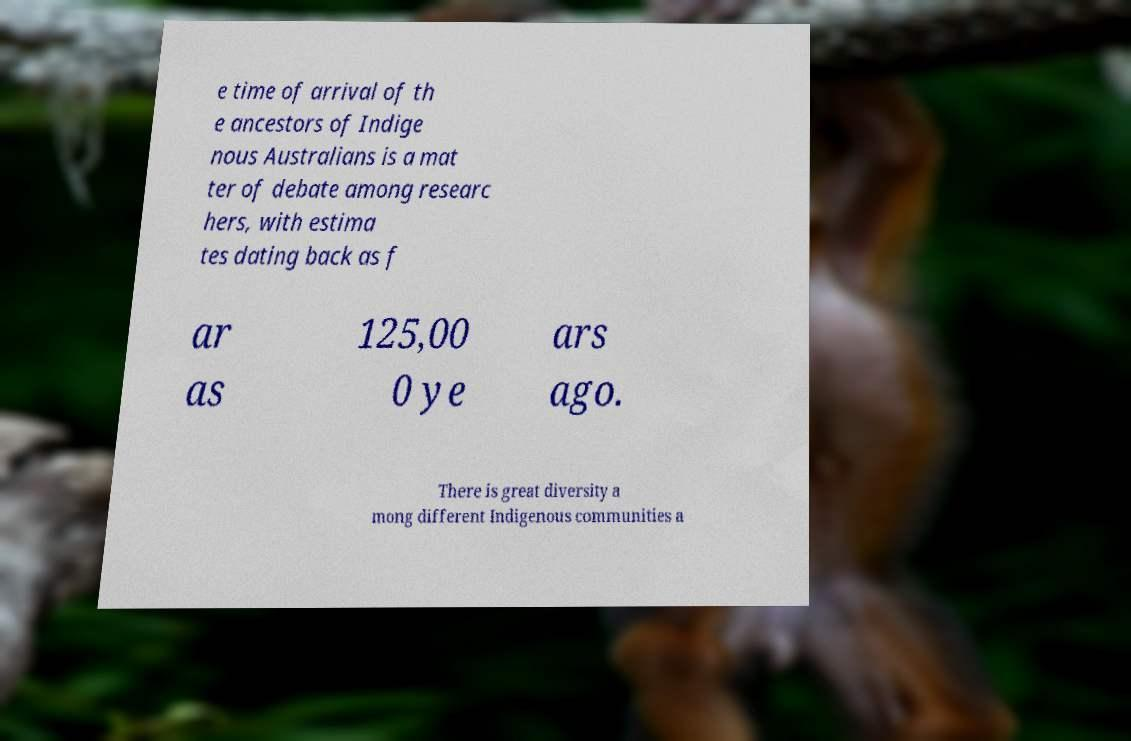Could you assist in decoding the text presented in this image and type it out clearly? e time of arrival of th e ancestors of Indige nous Australians is a mat ter of debate among researc hers, with estima tes dating back as f ar as 125,00 0 ye ars ago. There is great diversity a mong different Indigenous communities a 